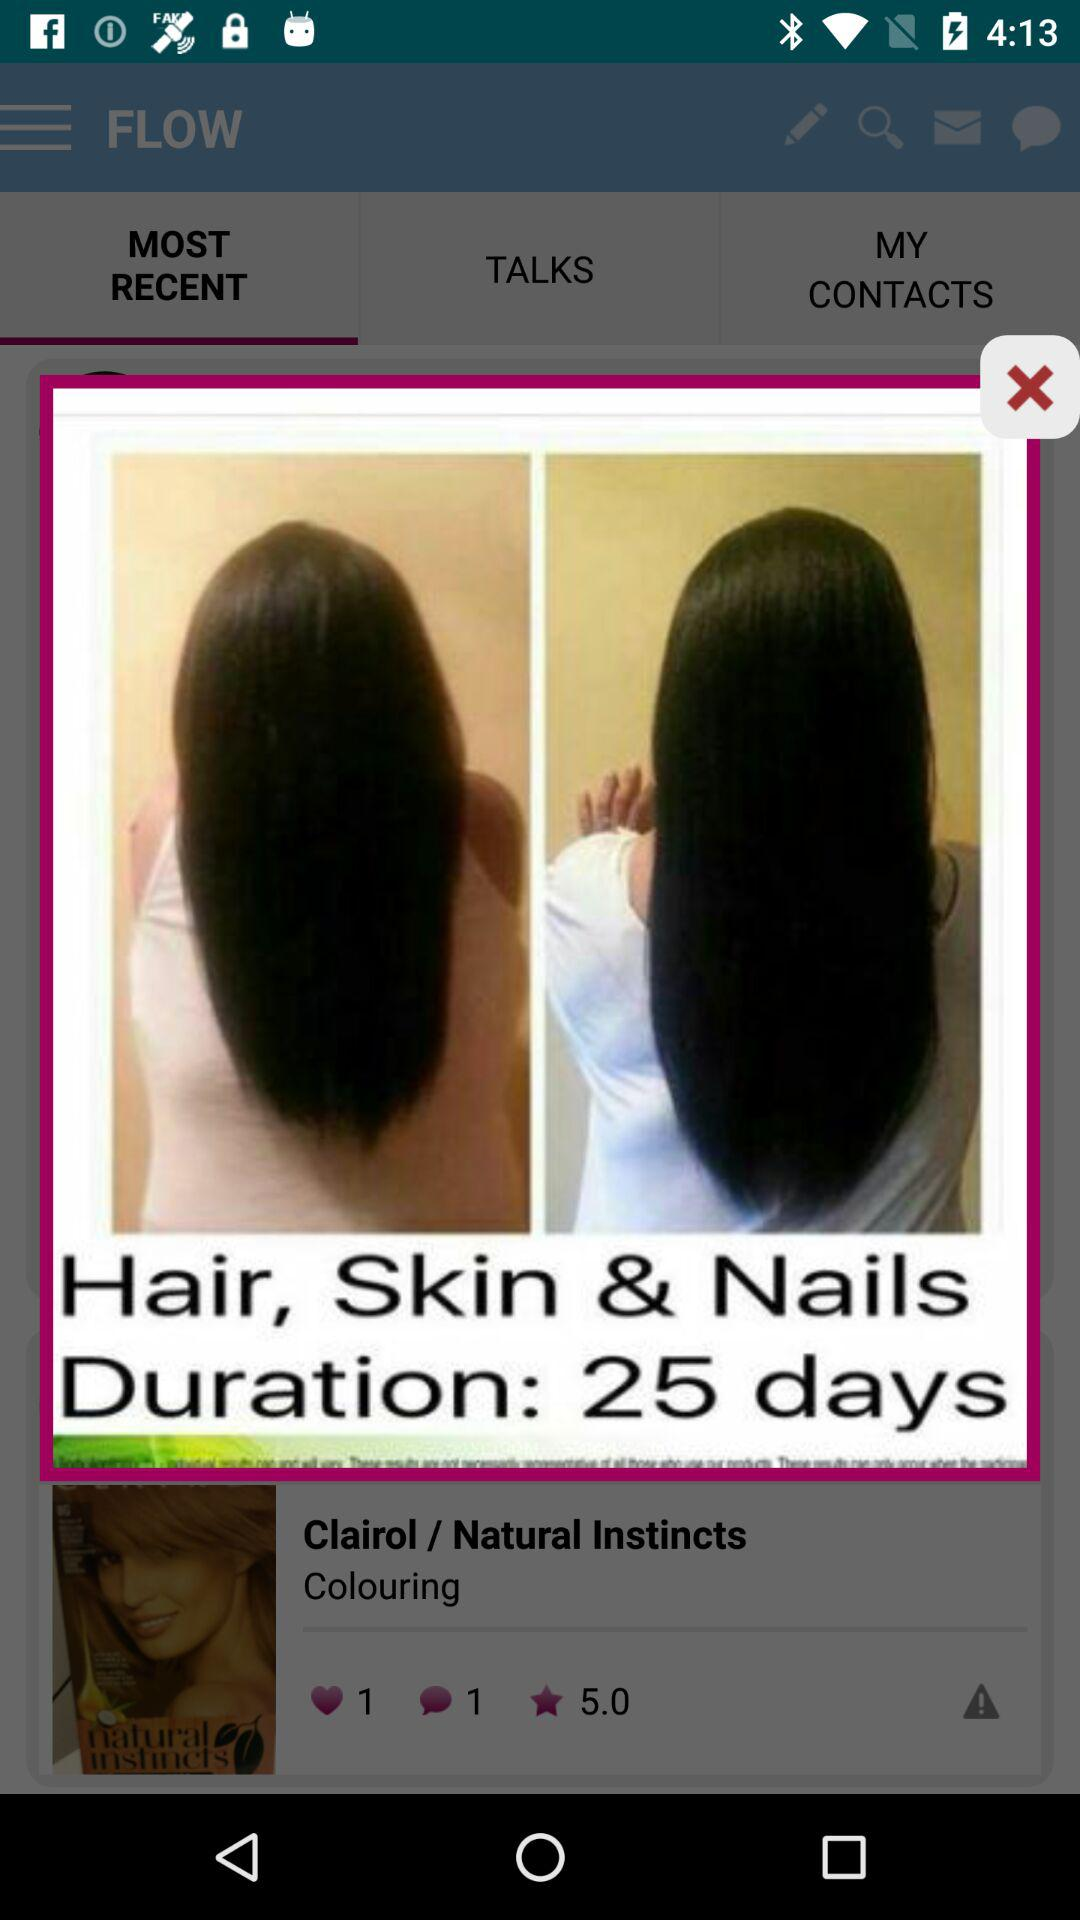How many comments are there for "Clairol / Natural Instincts"? There is 1 comment for "Clairol / Natural Instincts". 